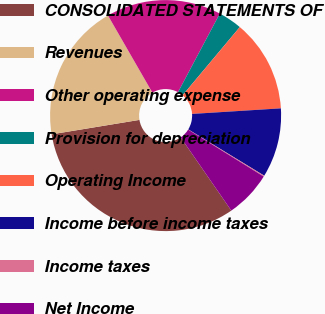Convert chart. <chart><loc_0><loc_0><loc_500><loc_500><pie_chart><fcel>CONSOLIDATED STATEMENTS OF<fcel>Revenues<fcel>Other operating expense<fcel>Provision for depreciation<fcel>Operating Income<fcel>Income before income taxes<fcel>Income taxes<fcel>Net Income<nl><fcel>32.04%<fcel>19.28%<fcel>16.09%<fcel>3.33%<fcel>12.9%<fcel>9.71%<fcel>0.14%<fcel>6.52%<nl></chart> 